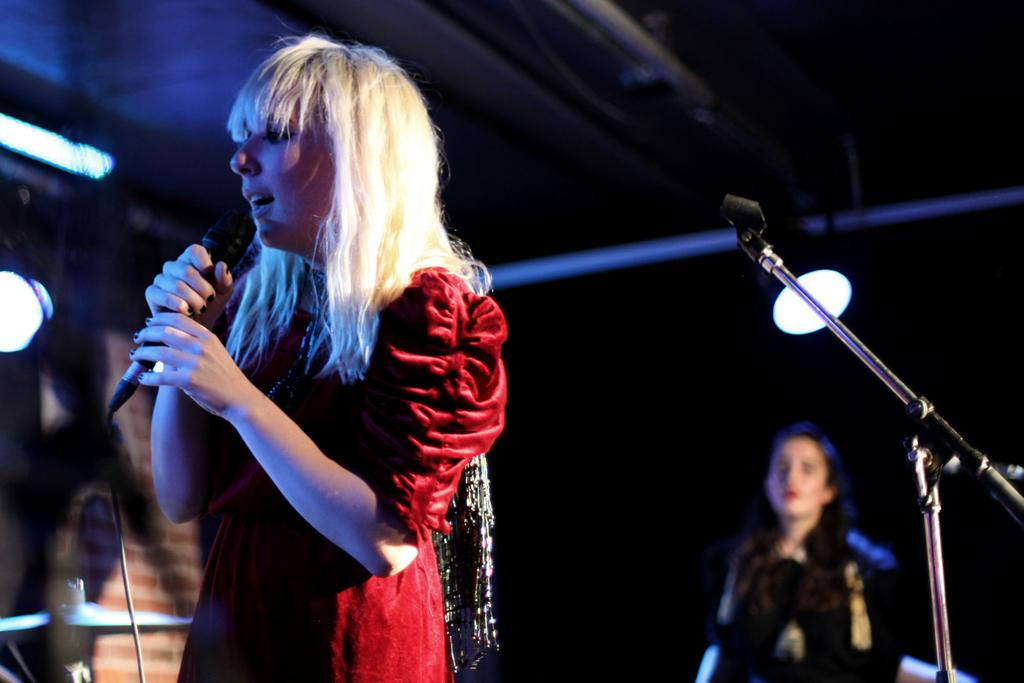What is the main subject of the image? There is a woman standing in the image. What is the woman holding in her hand? The woman is holding a mic in her hand. Can you describe the secondary subject in the image? There is another woman standing in the background of the image. How would you describe the quality of the image? The image is a little blurry. Where can the frogs be found in the image? There are no frogs present in the image. What type of cave is visible in the image? There is no cave present in the image. 